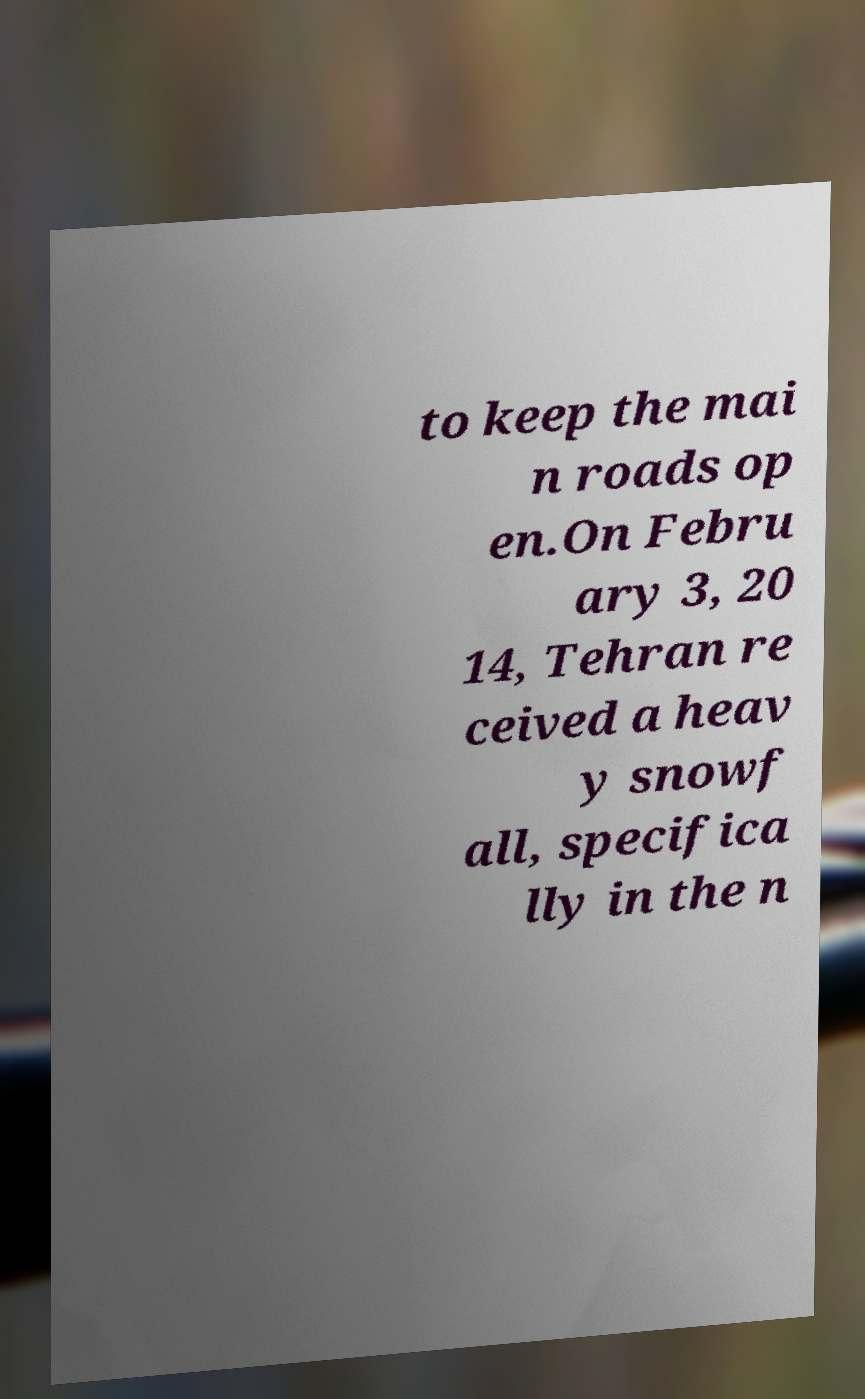For documentation purposes, I need the text within this image transcribed. Could you provide that? to keep the mai n roads op en.On Febru ary 3, 20 14, Tehran re ceived a heav y snowf all, specifica lly in the n 